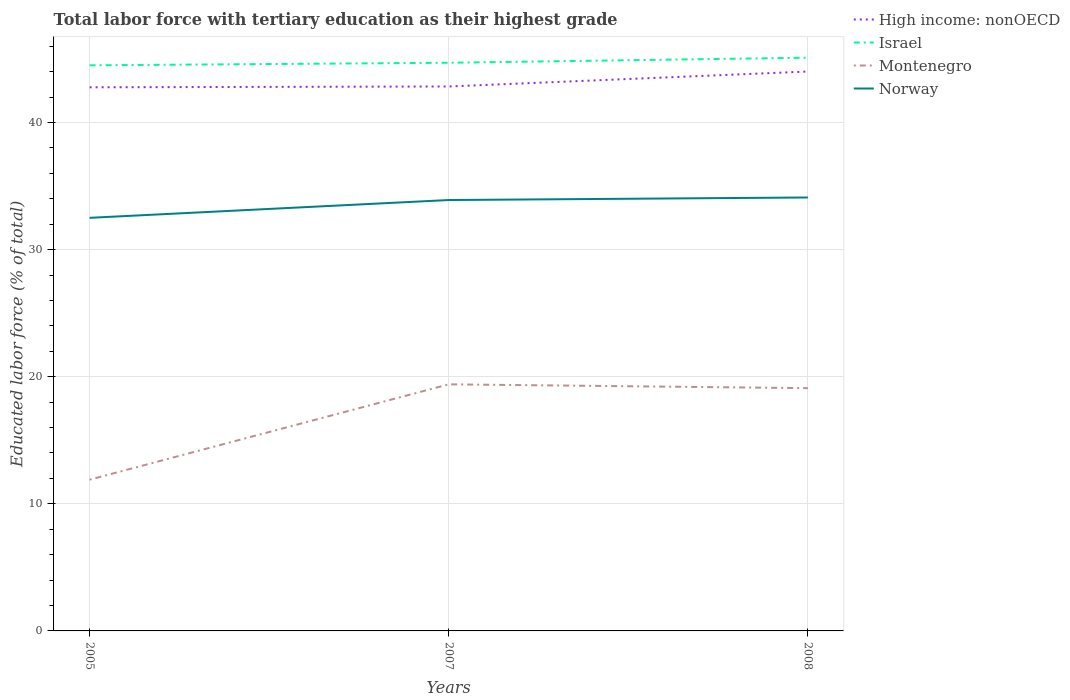Across all years, what is the maximum percentage of male labor force with tertiary education in Israel?
Your answer should be compact. 44.5. What is the total percentage of male labor force with tertiary education in Norway in the graph?
Your answer should be very brief. -1.6. What is the difference between the highest and the second highest percentage of male labor force with tertiary education in High income: nonOECD?
Offer a terse response. 1.24. What is the difference between the highest and the lowest percentage of male labor force with tertiary education in High income: nonOECD?
Offer a terse response. 1. How many lines are there?
Provide a succinct answer. 4. How many years are there in the graph?
Your answer should be very brief. 3. Are the values on the major ticks of Y-axis written in scientific E-notation?
Offer a very short reply. No. Does the graph contain any zero values?
Make the answer very short. No. Does the graph contain grids?
Provide a succinct answer. Yes. Where does the legend appear in the graph?
Offer a terse response. Top right. How many legend labels are there?
Provide a short and direct response. 4. What is the title of the graph?
Ensure brevity in your answer.  Total labor force with tertiary education as their highest grade. Does "Syrian Arab Republic" appear as one of the legend labels in the graph?
Your response must be concise. No. What is the label or title of the X-axis?
Provide a succinct answer. Years. What is the label or title of the Y-axis?
Offer a terse response. Educated labor force (% of total). What is the Educated labor force (% of total) in High income: nonOECD in 2005?
Make the answer very short. 42.77. What is the Educated labor force (% of total) in Israel in 2005?
Keep it short and to the point. 44.5. What is the Educated labor force (% of total) of Montenegro in 2005?
Your response must be concise. 11.9. What is the Educated labor force (% of total) in Norway in 2005?
Offer a very short reply. 32.5. What is the Educated labor force (% of total) of High income: nonOECD in 2007?
Offer a terse response. 42.83. What is the Educated labor force (% of total) of Israel in 2007?
Make the answer very short. 44.7. What is the Educated labor force (% of total) in Montenegro in 2007?
Provide a succinct answer. 19.4. What is the Educated labor force (% of total) of Norway in 2007?
Ensure brevity in your answer.  33.9. What is the Educated labor force (% of total) in High income: nonOECD in 2008?
Provide a succinct answer. 44.01. What is the Educated labor force (% of total) in Israel in 2008?
Your answer should be compact. 45.1. What is the Educated labor force (% of total) of Montenegro in 2008?
Ensure brevity in your answer.  19.1. What is the Educated labor force (% of total) in Norway in 2008?
Your answer should be compact. 34.1. Across all years, what is the maximum Educated labor force (% of total) in High income: nonOECD?
Offer a very short reply. 44.01. Across all years, what is the maximum Educated labor force (% of total) in Israel?
Give a very brief answer. 45.1. Across all years, what is the maximum Educated labor force (% of total) in Montenegro?
Ensure brevity in your answer.  19.4. Across all years, what is the maximum Educated labor force (% of total) in Norway?
Offer a terse response. 34.1. Across all years, what is the minimum Educated labor force (% of total) of High income: nonOECD?
Provide a short and direct response. 42.77. Across all years, what is the minimum Educated labor force (% of total) in Israel?
Make the answer very short. 44.5. Across all years, what is the minimum Educated labor force (% of total) in Montenegro?
Your response must be concise. 11.9. Across all years, what is the minimum Educated labor force (% of total) of Norway?
Make the answer very short. 32.5. What is the total Educated labor force (% of total) of High income: nonOECD in the graph?
Your answer should be very brief. 129.61. What is the total Educated labor force (% of total) of Israel in the graph?
Your response must be concise. 134.3. What is the total Educated labor force (% of total) of Montenegro in the graph?
Your answer should be very brief. 50.4. What is the total Educated labor force (% of total) of Norway in the graph?
Make the answer very short. 100.5. What is the difference between the Educated labor force (% of total) in High income: nonOECD in 2005 and that in 2007?
Give a very brief answer. -0.06. What is the difference between the Educated labor force (% of total) of Israel in 2005 and that in 2007?
Keep it short and to the point. -0.2. What is the difference between the Educated labor force (% of total) of High income: nonOECD in 2005 and that in 2008?
Provide a succinct answer. -1.24. What is the difference between the Educated labor force (% of total) of Montenegro in 2005 and that in 2008?
Provide a succinct answer. -7.2. What is the difference between the Educated labor force (% of total) in High income: nonOECD in 2007 and that in 2008?
Your answer should be very brief. -1.18. What is the difference between the Educated labor force (% of total) in Israel in 2007 and that in 2008?
Offer a terse response. -0.4. What is the difference between the Educated labor force (% of total) in Norway in 2007 and that in 2008?
Your response must be concise. -0.2. What is the difference between the Educated labor force (% of total) in High income: nonOECD in 2005 and the Educated labor force (% of total) in Israel in 2007?
Your response must be concise. -1.93. What is the difference between the Educated labor force (% of total) of High income: nonOECD in 2005 and the Educated labor force (% of total) of Montenegro in 2007?
Your response must be concise. 23.37. What is the difference between the Educated labor force (% of total) of High income: nonOECD in 2005 and the Educated labor force (% of total) of Norway in 2007?
Make the answer very short. 8.87. What is the difference between the Educated labor force (% of total) of Israel in 2005 and the Educated labor force (% of total) of Montenegro in 2007?
Keep it short and to the point. 25.1. What is the difference between the Educated labor force (% of total) of High income: nonOECD in 2005 and the Educated labor force (% of total) of Israel in 2008?
Make the answer very short. -2.33. What is the difference between the Educated labor force (% of total) of High income: nonOECD in 2005 and the Educated labor force (% of total) of Montenegro in 2008?
Your answer should be very brief. 23.67. What is the difference between the Educated labor force (% of total) in High income: nonOECD in 2005 and the Educated labor force (% of total) in Norway in 2008?
Provide a short and direct response. 8.67. What is the difference between the Educated labor force (% of total) of Israel in 2005 and the Educated labor force (% of total) of Montenegro in 2008?
Your answer should be compact. 25.4. What is the difference between the Educated labor force (% of total) of Montenegro in 2005 and the Educated labor force (% of total) of Norway in 2008?
Give a very brief answer. -22.2. What is the difference between the Educated labor force (% of total) of High income: nonOECD in 2007 and the Educated labor force (% of total) of Israel in 2008?
Give a very brief answer. -2.27. What is the difference between the Educated labor force (% of total) of High income: nonOECD in 2007 and the Educated labor force (% of total) of Montenegro in 2008?
Provide a short and direct response. 23.73. What is the difference between the Educated labor force (% of total) of High income: nonOECD in 2007 and the Educated labor force (% of total) of Norway in 2008?
Your answer should be compact. 8.73. What is the difference between the Educated labor force (% of total) in Israel in 2007 and the Educated labor force (% of total) in Montenegro in 2008?
Provide a succinct answer. 25.6. What is the difference between the Educated labor force (% of total) of Montenegro in 2007 and the Educated labor force (% of total) of Norway in 2008?
Offer a very short reply. -14.7. What is the average Educated labor force (% of total) of High income: nonOECD per year?
Your response must be concise. 43.2. What is the average Educated labor force (% of total) of Israel per year?
Provide a short and direct response. 44.77. What is the average Educated labor force (% of total) in Montenegro per year?
Offer a very short reply. 16.8. What is the average Educated labor force (% of total) of Norway per year?
Offer a terse response. 33.5. In the year 2005, what is the difference between the Educated labor force (% of total) of High income: nonOECD and Educated labor force (% of total) of Israel?
Give a very brief answer. -1.73. In the year 2005, what is the difference between the Educated labor force (% of total) in High income: nonOECD and Educated labor force (% of total) in Montenegro?
Provide a succinct answer. 30.87. In the year 2005, what is the difference between the Educated labor force (% of total) in High income: nonOECD and Educated labor force (% of total) in Norway?
Offer a terse response. 10.27. In the year 2005, what is the difference between the Educated labor force (% of total) of Israel and Educated labor force (% of total) of Montenegro?
Your answer should be very brief. 32.6. In the year 2005, what is the difference between the Educated labor force (% of total) of Montenegro and Educated labor force (% of total) of Norway?
Offer a very short reply. -20.6. In the year 2007, what is the difference between the Educated labor force (% of total) of High income: nonOECD and Educated labor force (% of total) of Israel?
Give a very brief answer. -1.87. In the year 2007, what is the difference between the Educated labor force (% of total) of High income: nonOECD and Educated labor force (% of total) of Montenegro?
Your response must be concise. 23.43. In the year 2007, what is the difference between the Educated labor force (% of total) of High income: nonOECD and Educated labor force (% of total) of Norway?
Offer a very short reply. 8.93. In the year 2007, what is the difference between the Educated labor force (% of total) in Israel and Educated labor force (% of total) in Montenegro?
Give a very brief answer. 25.3. In the year 2007, what is the difference between the Educated labor force (% of total) of Montenegro and Educated labor force (% of total) of Norway?
Provide a short and direct response. -14.5. In the year 2008, what is the difference between the Educated labor force (% of total) in High income: nonOECD and Educated labor force (% of total) in Israel?
Provide a succinct answer. -1.09. In the year 2008, what is the difference between the Educated labor force (% of total) of High income: nonOECD and Educated labor force (% of total) of Montenegro?
Offer a terse response. 24.91. In the year 2008, what is the difference between the Educated labor force (% of total) of High income: nonOECD and Educated labor force (% of total) of Norway?
Your answer should be very brief. 9.91. In the year 2008, what is the difference between the Educated labor force (% of total) of Israel and Educated labor force (% of total) of Montenegro?
Offer a terse response. 26. In the year 2008, what is the difference between the Educated labor force (% of total) in Israel and Educated labor force (% of total) in Norway?
Keep it short and to the point. 11. What is the ratio of the Educated labor force (% of total) of High income: nonOECD in 2005 to that in 2007?
Give a very brief answer. 1. What is the ratio of the Educated labor force (% of total) of Montenegro in 2005 to that in 2007?
Give a very brief answer. 0.61. What is the ratio of the Educated labor force (% of total) in Norway in 2005 to that in 2007?
Keep it short and to the point. 0.96. What is the ratio of the Educated labor force (% of total) in High income: nonOECD in 2005 to that in 2008?
Make the answer very short. 0.97. What is the ratio of the Educated labor force (% of total) of Israel in 2005 to that in 2008?
Provide a succinct answer. 0.99. What is the ratio of the Educated labor force (% of total) of Montenegro in 2005 to that in 2008?
Offer a very short reply. 0.62. What is the ratio of the Educated labor force (% of total) in Norway in 2005 to that in 2008?
Your answer should be compact. 0.95. What is the ratio of the Educated labor force (% of total) of High income: nonOECD in 2007 to that in 2008?
Give a very brief answer. 0.97. What is the ratio of the Educated labor force (% of total) in Montenegro in 2007 to that in 2008?
Provide a succinct answer. 1.02. What is the difference between the highest and the second highest Educated labor force (% of total) of High income: nonOECD?
Offer a very short reply. 1.18. What is the difference between the highest and the second highest Educated labor force (% of total) of Israel?
Offer a very short reply. 0.4. What is the difference between the highest and the second highest Educated labor force (% of total) of Montenegro?
Give a very brief answer. 0.3. What is the difference between the highest and the second highest Educated labor force (% of total) of Norway?
Give a very brief answer. 0.2. What is the difference between the highest and the lowest Educated labor force (% of total) in High income: nonOECD?
Your response must be concise. 1.24. What is the difference between the highest and the lowest Educated labor force (% of total) in Norway?
Keep it short and to the point. 1.6. 